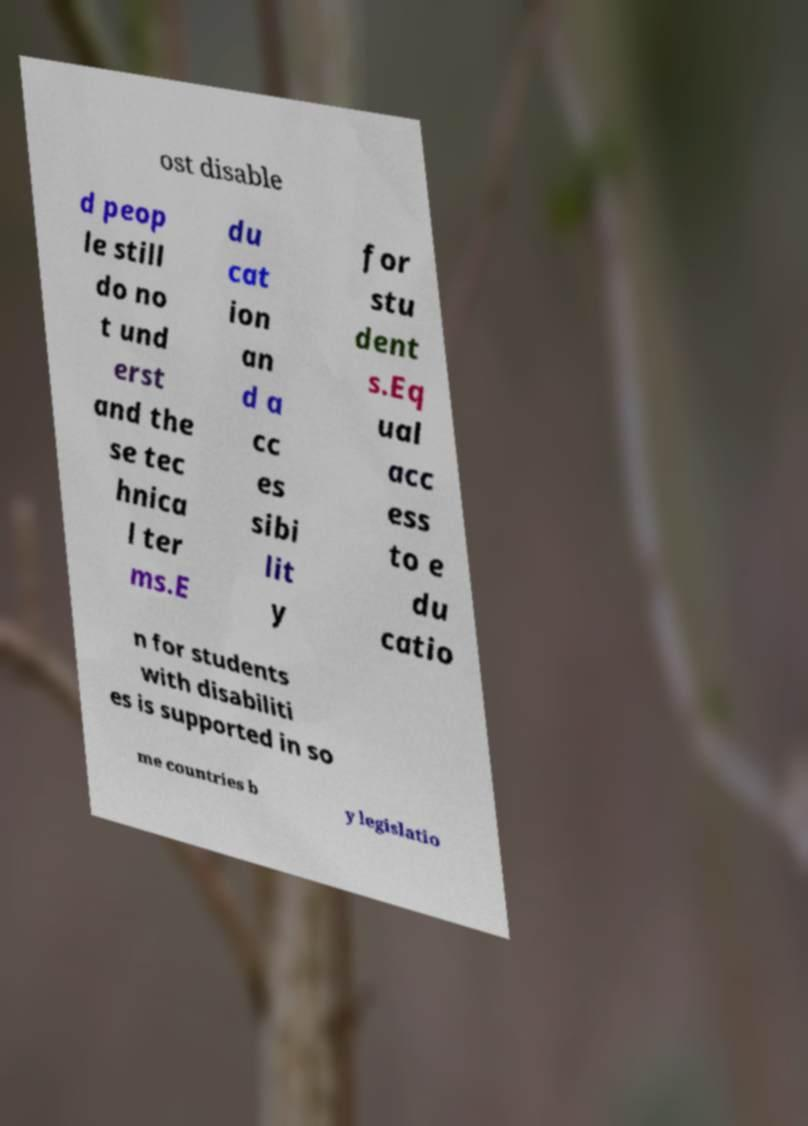Could you assist in decoding the text presented in this image and type it out clearly? ost disable d peop le still do no t und erst and the se tec hnica l ter ms.E du cat ion an d a cc es sibi lit y for stu dent s.Eq ual acc ess to e du catio n for students with disabiliti es is supported in so me countries b y legislatio 